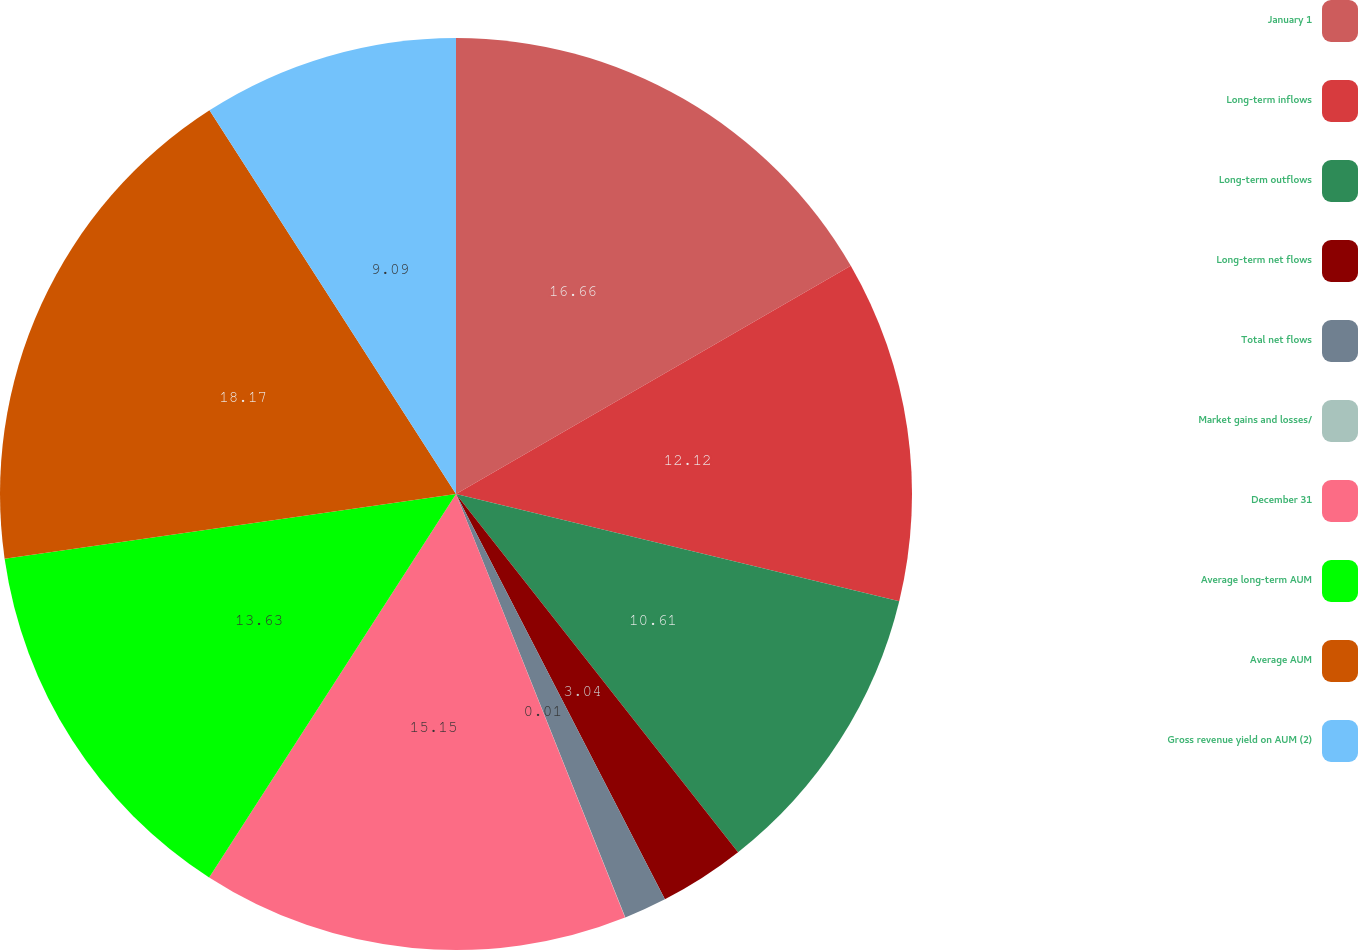Convert chart to OTSL. <chart><loc_0><loc_0><loc_500><loc_500><pie_chart><fcel>January 1<fcel>Long-term inflows<fcel>Long-term outflows<fcel>Long-term net flows<fcel>Total net flows<fcel>Market gains and losses/<fcel>December 31<fcel>Average long-term AUM<fcel>Average AUM<fcel>Gross revenue yield on AUM (2)<nl><fcel>16.66%<fcel>12.12%<fcel>10.61%<fcel>3.04%<fcel>1.52%<fcel>0.01%<fcel>15.15%<fcel>13.63%<fcel>18.18%<fcel>9.09%<nl></chart> 